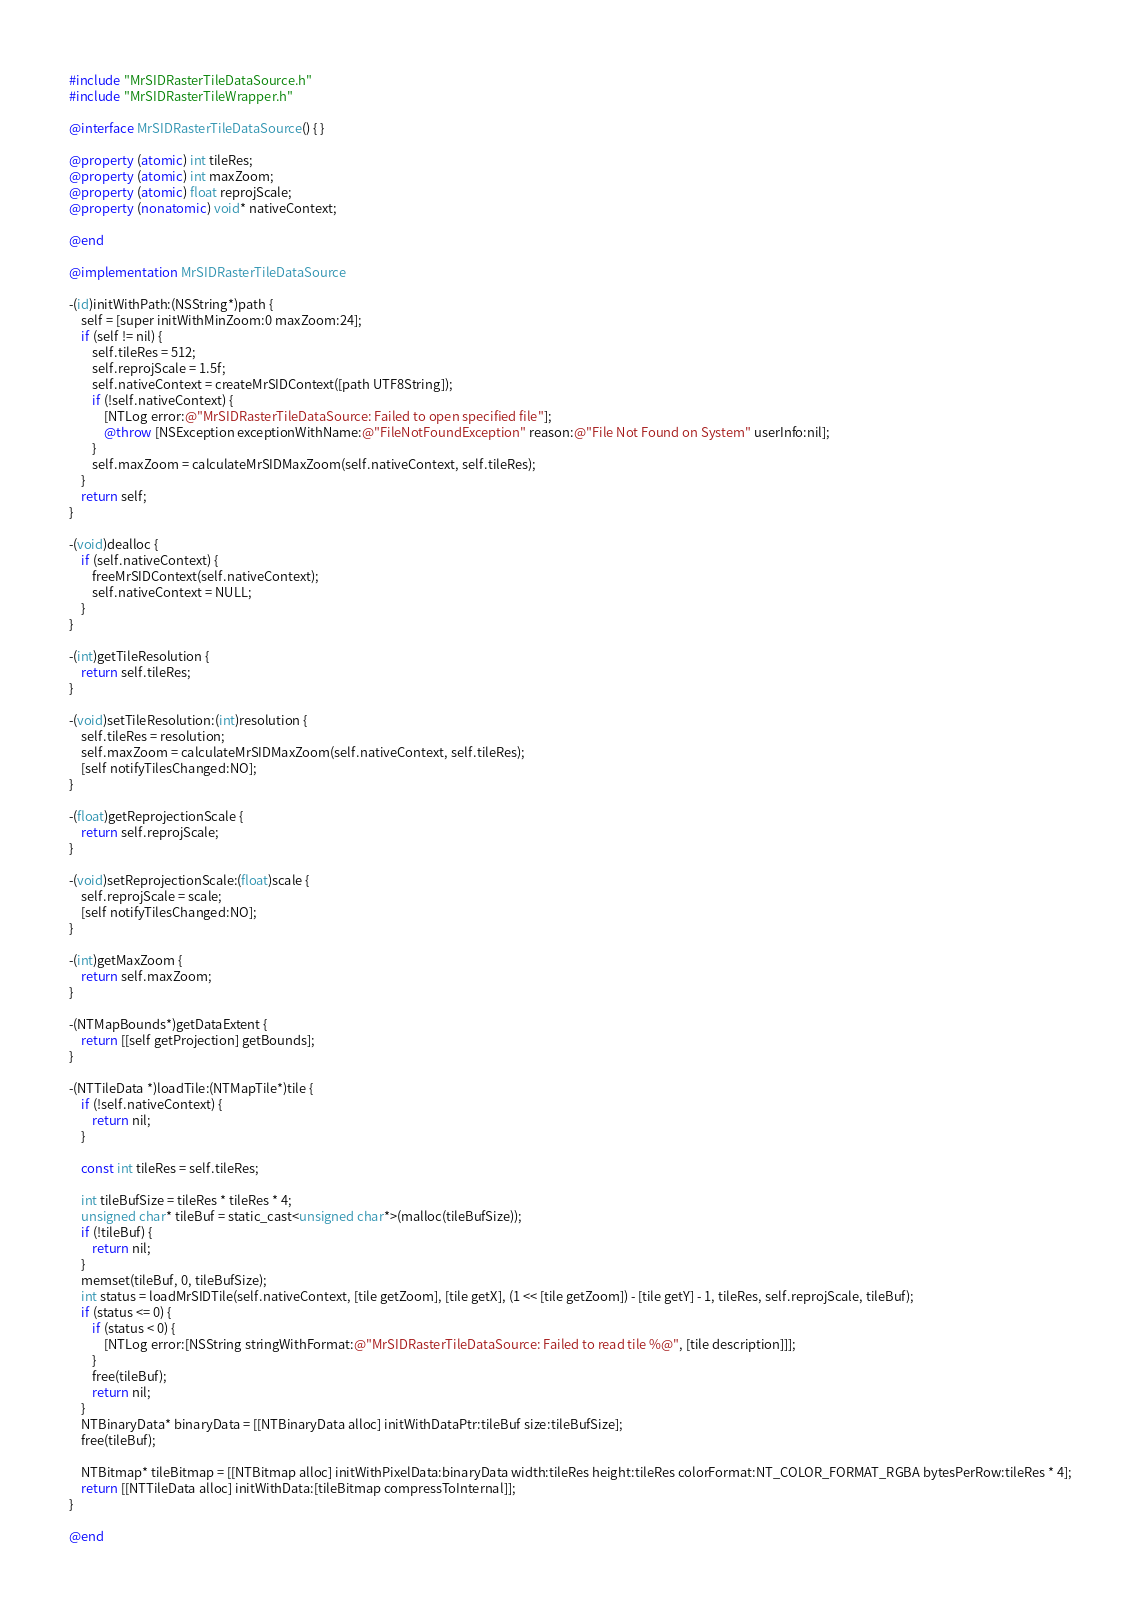<code> <loc_0><loc_0><loc_500><loc_500><_ObjectiveC_>#include "MrSIDRasterTileDataSource.h"
#include "MrSIDRasterTileWrapper.h"

@interface MrSIDRasterTileDataSource() { }

@property (atomic) int tileRes;
@property (atomic) int maxZoom;
@property (atomic) float reprojScale;
@property (nonatomic) void* nativeContext;

@end

@implementation MrSIDRasterTileDataSource

-(id)initWithPath:(NSString*)path {
    self = [super initWithMinZoom:0 maxZoom:24];
    if (self != nil) {
        self.tileRes = 512;
        self.reprojScale = 1.5f;
        self.nativeContext = createMrSIDContext([path UTF8String]);
        if (!self.nativeContext) {
            [NTLog error:@"MrSIDRasterTileDataSource: Failed to open specified file"];
            @throw [NSException exceptionWithName:@"FileNotFoundException" reason:@"File Not Found on System" userInfo:nil];
        }
        self.maxZoom = calculateMrSIDMaxZoom(self.nativeContext, self.tileRes);
    }
    return self;
}

-(void)dealloc {
    if (self.nativeContext) {
        freeMrSIDContext(self.nativeContext);
        self.nativeContext = NULL;
    }
}

-(int)getTileResolution {
    return self.tileRes;
}

-(void)setTileResolution:(int)resolution {
    self.tileRes = resolution;
    self.maxZoom = calculateMrSIDMaxZoom(self.nativeContext, self.tileRes);
    [self notifyTilesChanged:NO];
}

-(float)getReprojectionScale {
    return self.reprojScale;
}

-(void)setReprojectionScale:(float)scale {
    self.reprojScale = scale;
    [self notifyTilesChanged:NO];
}

-(int)getMaxZoom {
    return self.maxZoom;
}

-(NTMapBounds*)getDataExtent {
    return [[self getProjection] getBounds];
}

-(NTTileData *)loadTile:(NTMapTile*)tile {
    if (!self.nativeContext) {
        return nil;
    }

    const int tileRes = self.tileRes;

    int tileBufSize = tileRes * tileRes * 4;
    unsigned char* tileBuf = static_cast<unsigned char*>(malloc(tileBufSize));
    if (!tileBuf) {
        return nil;
    }
    memset(tileBuf, 0, tileBufSize);
    int status = loadMrSIDTile(self.nativeContext, [tile getZoom], [tile getX], (1 << [tile getZoom]) - [tile getY] - 1, tileRes, self.reprojScale, tileBuf);
    if (status <= 0) {
        if (status < 0) {
            [NTLog error:[NSString stringWithFormat:@"MrSIDRasterTileDataSource: Failed to read tile %@", [tile description]]];
        }
        free(tileBuf);
        return nil;
    }
    NTBinaryData* binaryData = [[NTBinaryData alloc] initWithDataPtr:tileBuf size:tileBufSize];
    free(tileBuf);

    NTBitmap* tileBitmap = [[NTBitmap alloc] initWithPixelData:binaryData width:tileRes height:tileRes colorFormat:NT_COLOR_FORMAT_RGBA bytesPerRow:tileRes * 4];
    return [[NTTileData alloc] initWithData:[tileBitmap compressToInternal]];
}

@end
</code> 